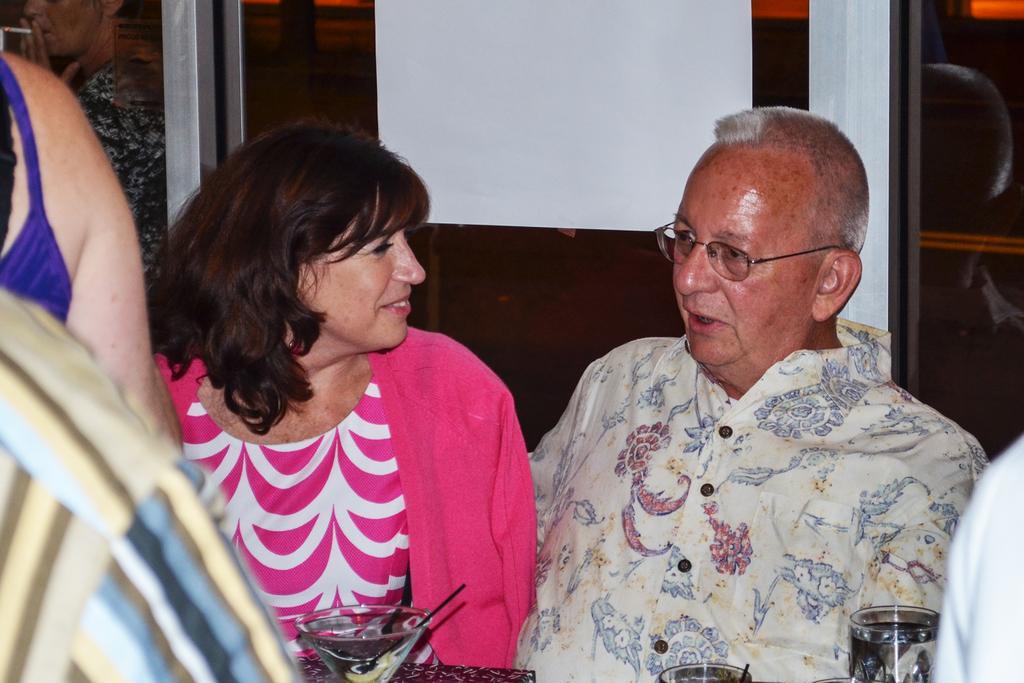Can you describe this image briefly? In this picture we can see a group of people and some people are sitting. In front of the people there are glass and behind the people it is looking like a glass wall. 